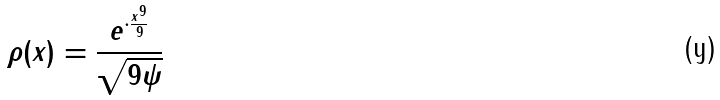Convert formula to latex. <formula><loc_0><loc_0><loc_500><loc_500>\rho ( x ) = \frac { e ^ { \cdot \frac { x ^ { 9 } } { 9 } } } { \sqrt { 9 \psi } }</formula> 